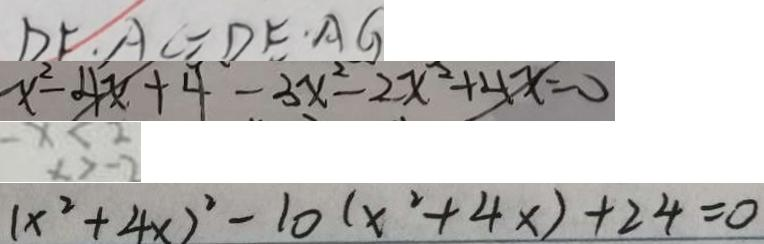<formula> <loc_0><loc_0><loc_500><loc_500>D F \cdot A C = D E \cdot A G 
 x ^ { 2 } - 4 x + 4 - 3 x ^ { 2 } - 2 x ^ { 2 } + 4 x = 0 
 - x < 2 
 ( x ^ { 2 } + 4 x ) ^ { 2 } - 1 0 ( x ^ { 2 } + 4 x ) + 2 4 = 0</formula> 